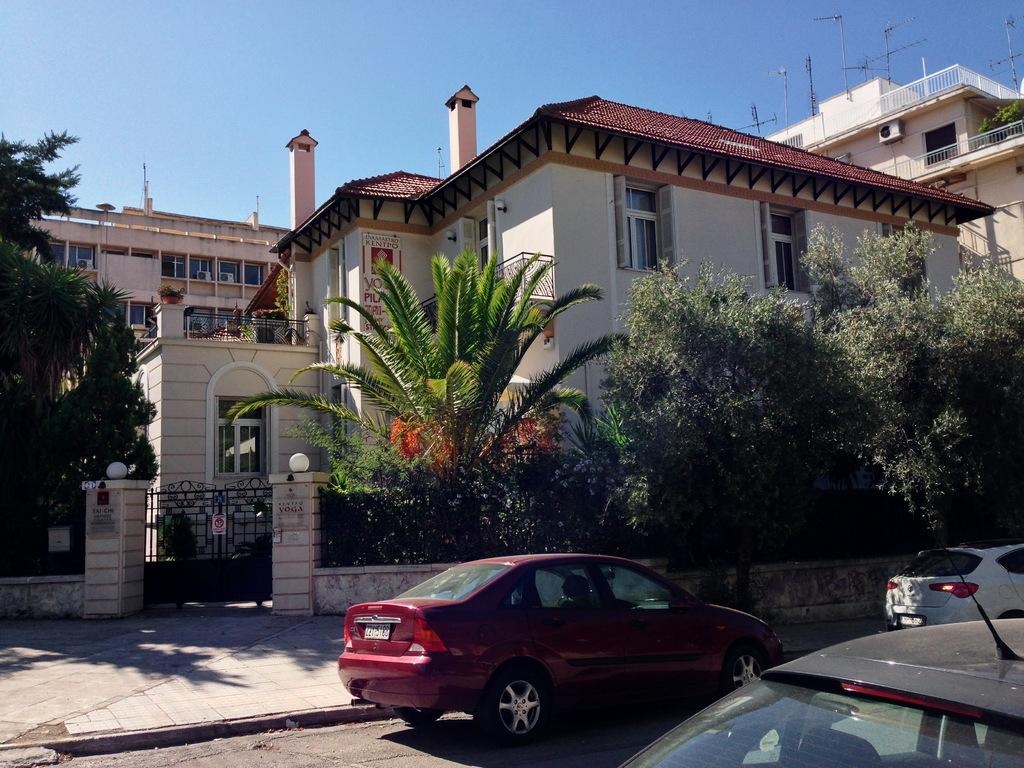What types of objects can be seen in the image? There are vehicles in the image. Can you describe one of the vehicles? One of the vehicles is red. What can be seen in the background of the image? There are trees, a building, and the sky visible in the background of the image. What color are the trees in the image? The trees are green. How would you describe the building in the background? The building has cream and maroon colors. What color is the sky in the image? The sky is blue. How many deer can be seen grazing in the image? There are no deer present in the image. What type of hen is sitting on the roof of the building in the image? There is no hen present in the image; the building has cream and maroon colors. 